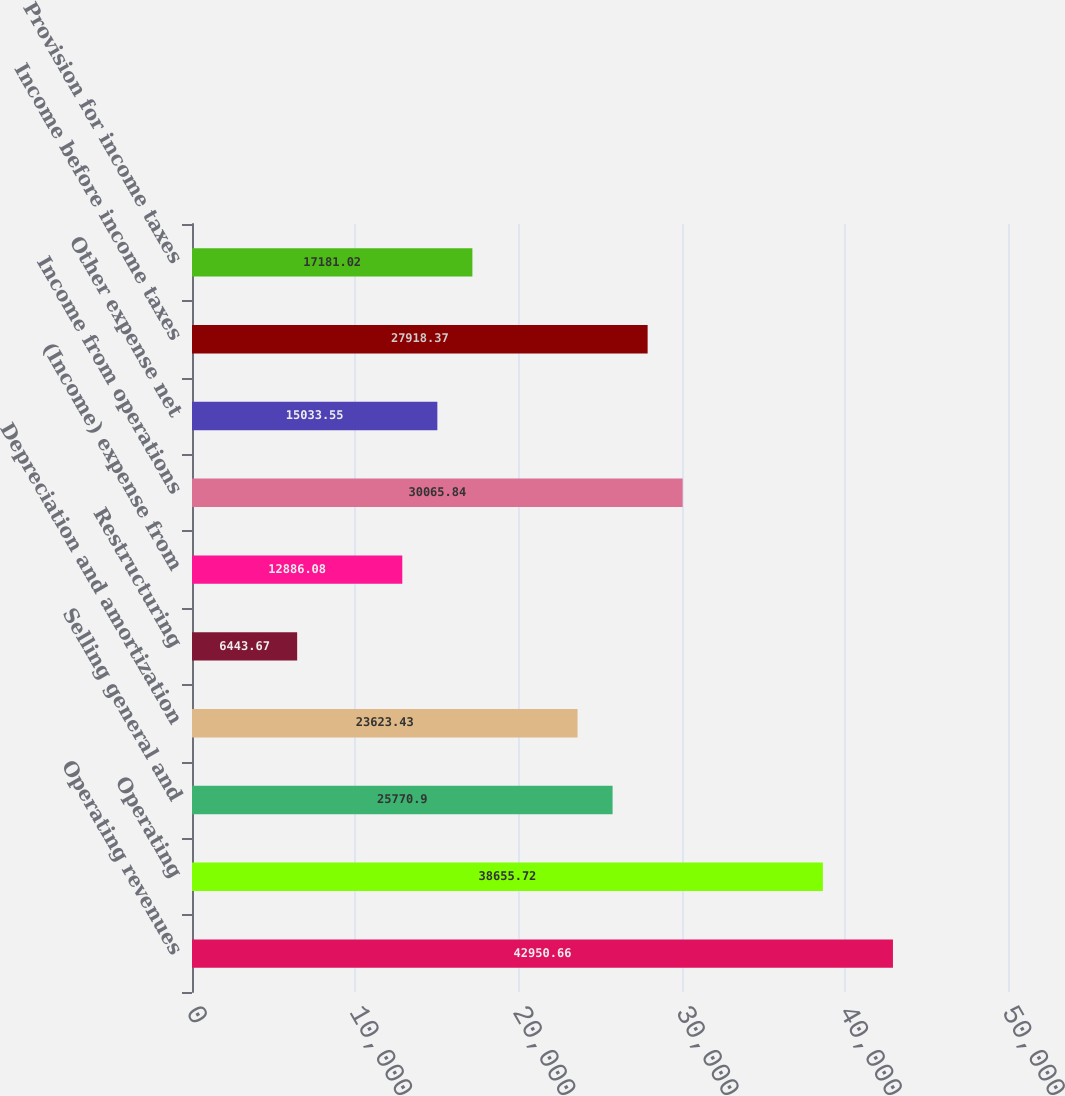Convert chart to OTSL. <chart><loc_0><loc_0><loc_500><loc_500><bar_chart><fcel>Operating revenues<fcel>Operating<fcel>Selling general and<fcel>Depreciation and amortization<fcel>Restructuring<fcel>(Income) expense from<fcel>Income from operations<fcel>Other expense net<fcel>Income before income taxes<fcel>Provision for income taxes<nl><fcel>42950.7<fcel>38655.7<fcel>25770.9<fcel>23623.4<fcel>6443.67<fcel>12886.1<fcel>30065.8<fcel>15033.5<fcel>27918.4<fcel>17181<nl></chart> 